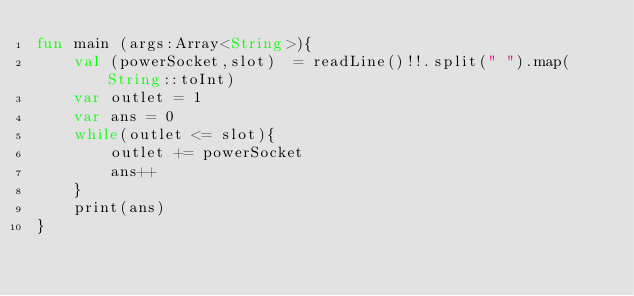Convert code to text. <code><loc_0><loc_0><loc_500><loc_500><_Kotlin_>fun main (args:Array<String>){
    val (powerSocket,slot)  = readLine()!!.split(" ").map(String::toInt)
    var outlet = 1
    var ans = 0
    while(outlet <= slot){
        outlet += powerSocket
        ans++
    }
    print(ans)
}</code> 